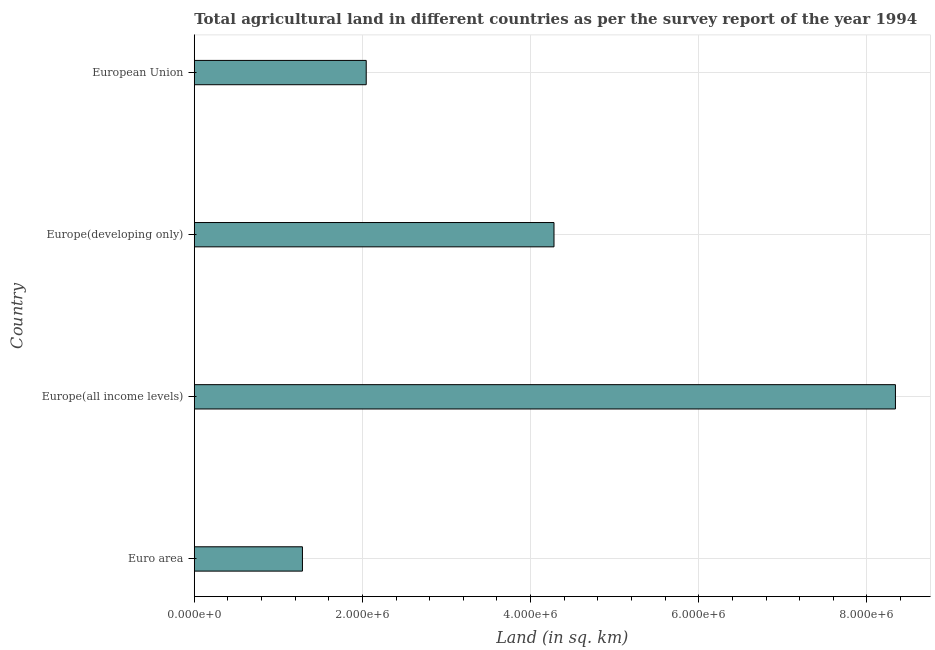Does the graph contain grids?
Provide a succinct answer. Yes. What is the title of the graph?
Offer a very short reply. Total agricultural land in different countries as per the survey report of the year 1994. What is the label or title of the X-axis?
Your response must be concise. Land (in sq. km). What is the agricultural land in Euro area?
Ensure brevity in your answer.  1.29e+06. Across all countries, what is the maximum agricultural land?
Your answer should be very brief. 8.34e+06. Across all countries, what is the minimum agricultural land?
Your answer should be very brief. 1.29e+06. In which country was the agricultural land maximum?
Ensure brevity in your answer.  Europe(all income levels). In which country was the agricultural land minimum?
Give a very brief answer. Euro area. What is the sum of the agricultural land?
Provide a succinct answer. 1.59e+07. What is the difference between the agricultural land in Euro area and Europe(all income levels)?
Your response must be concise. -7.05e+06. What is the average agricultural land per country?
Give a very brief answer. 3.99e+06. What is the median agricultural land?
Your response must be concise. 3.16e+06. In how many countries, is the agricultural land greater than 7600000 sq. km?
Your answer should be compact. 1. What is the ratio of the agricultural land in Euro area to that in Europe(developing only)?
Offer a very short reply. 0.3. What is the difference between the highest and the second highest agricultural land?
Provide a succinct answer. 4.06e+06. What is the difference between the highest and the lowest agricultural land?
Your answer should be very brief. 7.05e+06. Are all the bars in the graph horizontal?
Offer a terse response. Yes. What is the difference between two consecutive major ticks on the X-axis?
Provide a short and direct response. 2.00e+06. What is the Land (in sq. km) in Euro area?
Your answer should be compact. 1.29e+06. What is the Land (in sq. km) of Europe(all income levels)?
Provide a short and direct response. 8.34e+06. What is the Land (in sq. km) in Europe(developing only)?
Your response must be concise. 4.28e+06. What is the Land (in sq. km) in European Union?
Offer a very short reply. 2.04e+06. What is the difference between the Land (in sq. km) in Euro area and Europe(all income levels)?
Make the answer very short. -7.05e+06. What is the difference between the Land (in sq. km) in Euro area and Europe(developing only)?
Ensure brevity in your answer.  -2.99e+06. What is the difference between the Land (in sq. km) in Euro area and European Union?
Give a very brief answer. -7.58e+05. What is the difference between the Land (in sq. km) in Europe(all income levels) and Europe(developing only)?
Your response must be concise. 4.06e+06. What is the difference between the Land (in sq. km) in Europe(all income levels) and European Union?
Your answer should be very brief. 6.29e+06. What is the difference between the Land (in sq. km) in Europe(developing only) and European Union?
Give a very brief answer. 2.23e+06. What is the ratio of the Land (in sq. km) in Euro area to that in Europe(all income levels)?
Offer a very short reply. 0.15. What is the ratio of the Land (in sq. km) in Euro area to that in Europe(developing only)?
Ensure brevity in your answer.  0.3. What is the ratio of the Land (in sq. km) in Euro area to that in European Union?
Provide a succinct answer. 0.63. What is the ratio of the Land (in sq. km) in Europe(all income levels) to that in Europe(developing only)?
Offer a terse response. 1.95. What is the ratio of the Land (in sq. km) in Europe(all income levels) to that in European Union?
Keep it short and to the point. 4.08. What is the ratio of the Land (in sq. km) in Europe(developing only) to that in European Union?
Your response must be concise. 2.09. 